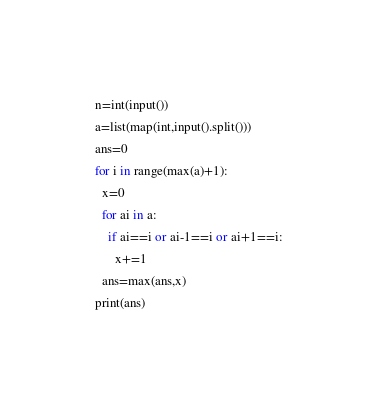<code> <loc_0><loc_0><loc_500><loc_500><_Python_>n=int(input())
a=list(map(int,input().split()))
ans=0
for i in range(max(a)+1):
  x=0
  for ai in a:
    if ai==i or ai-1==i or ai+1==i:
      x+=1
  ans=max(ans,x)
print(ans)</code> 